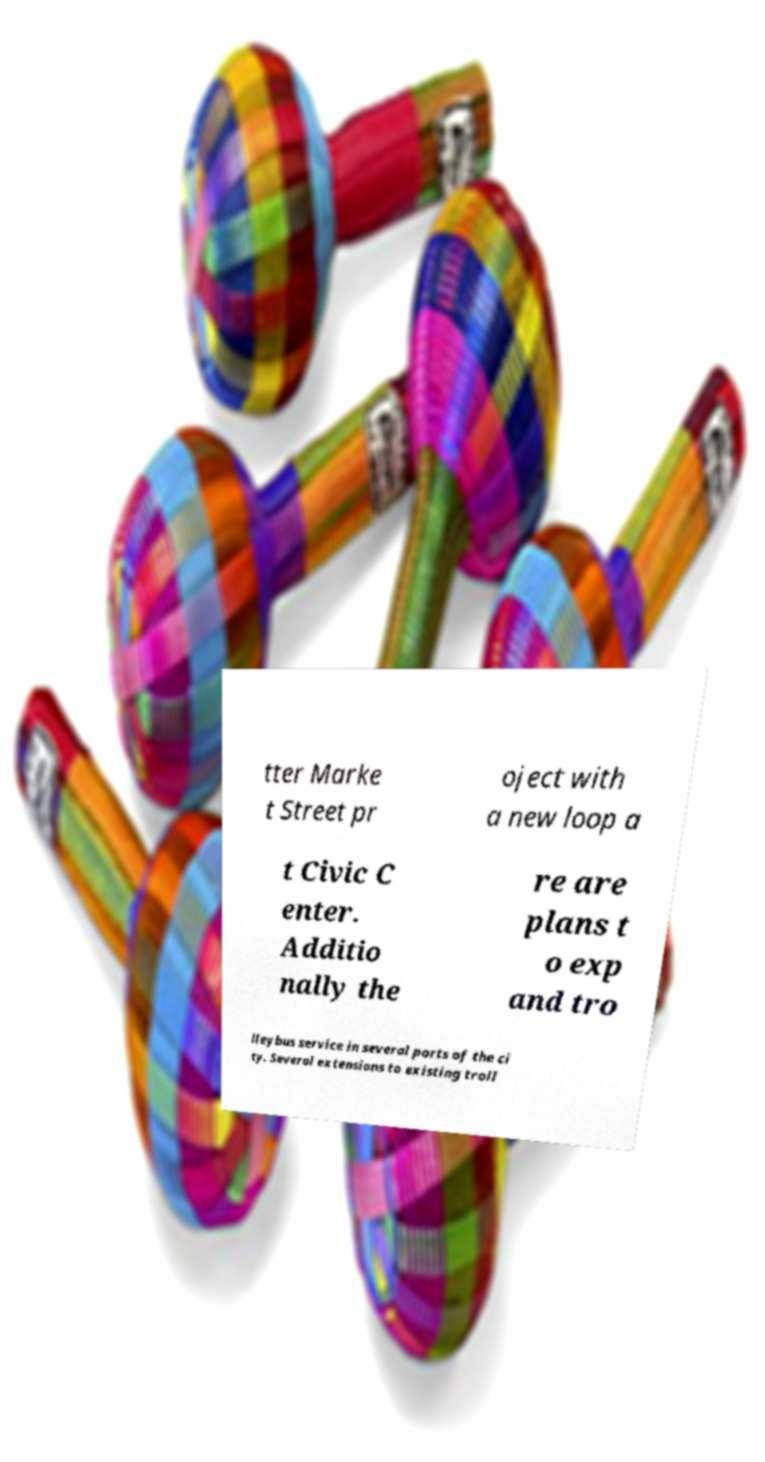Please identify and transcribe the text found in this image. tter Marke t Street pr oject with a new loop a t Civic C enter. Additio nally the re are plans t o exp and tro lleybus service in several parts of the ci ty. Several extensions to existing troll 